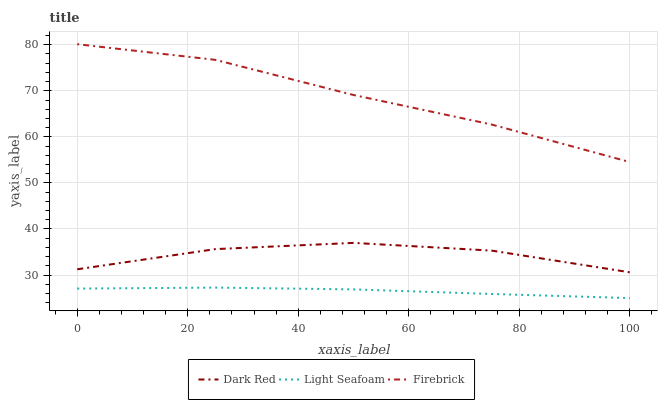Does Light Seafoam have the minimum area under the curve?
Answer yes or no. Yes. Does Firebrick have the maximum area under the curve?
Answer yes or no. Yes. Does Firebrick have the minimum area under the curve?
Answer yes or no. No. Does Light Seafoam have the maximum area under the curve?
Answer yes or no. No. Is Light Seafoam the smoothest?
Answer yes or no. Yes. Is Dark Red the roughest?
Answer yes or no. Yes. Is Firebrick the smoothest?
Answer yes or no. No. Is Firebrick the roughest?
Answer yes or no. No. Does Light Seafoam have the lowest value?
Answer yes or no. Yes. Does Firebrick have the lowest value?
Answer yes or no. No. Does Firebrick have the highest value?
Answer yes or no. Yes. Does Light Seafoam have the highest value?
Answer yes or no. No. Is Dark Red less than Firebrick?
Answer yes or no. Yes. Is Firebrick greater than Light Seafoam?
Answer yes or no. Yes. Does Dark Red intersect Firebrick?
Answer yes or no. No. 